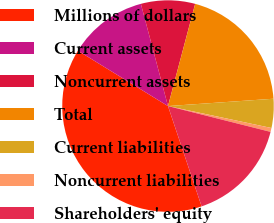Convert chart to OTSL. <chart><loc_0><loc_0><loc_500><loc_500><pie_chart><fcel>Millions of dollars<fcel>Current assets<fcel>Noncurrent assets<fcel>Total<fcel>Current liabilities<fcel>Noncurrent liabilities<fcel>Shareholders' equity<nl><fcel>38.92%<fcel>12.1%<fcel>8.26%<fcel>19.76%<fcel>4.43%<fcel>0.6%<fcel>15.93%<nl></chart> 